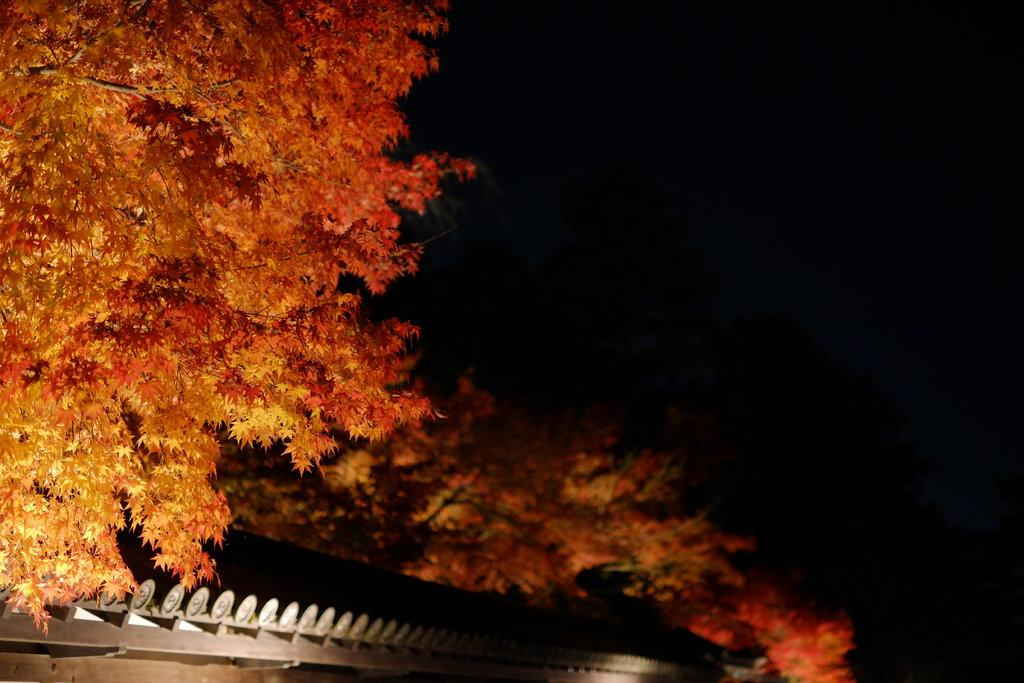What type of structure is visible in the image? There is a house in the image. What other natural elements can be seen in the image? There are trees in the image. What is visible in the background of the image? The sky is visible in the background of the image. Where is the dirt pile located in the image? There is no dirt pile present in the image. What type of food is being served in the lunchroom in the image? There is no lunchroom present in the image. 